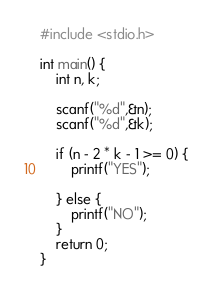Convert code to text. <code><loc_0><loc_0><loc_500><loc_500><_C_>#include <stdio.h>

int main() {
    int n, k;
    
    scanf("%d",&n);
    scanf("%d",&k);
    
    if (n - 2 * k - 1 >= 0) {
        printf("YES");
    
    } else {
        printf("NO");
    }
    return 0;
}</code> 